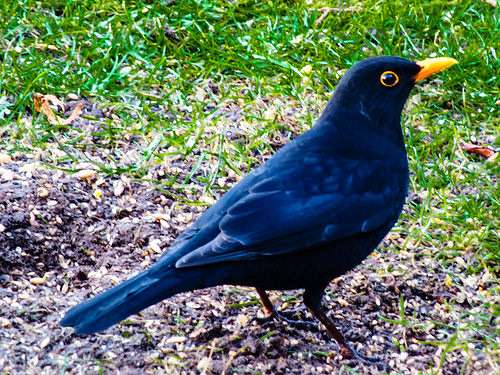<image>
Can you confirm if the bird is on the grass? Yes. Looking at the image, I can see the bird is positioned on top of the grass, with the grass providing support. 